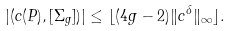<formula> <loc_0><loc_0><loc_500><loc_500>| ( c ( P ) , [ \Sigma _ { g } ] ) | \leq \lfloor ( 4 g - 2 ) \| c ^ { \delta } \| _ { \infty } \rfloor .</formula> 